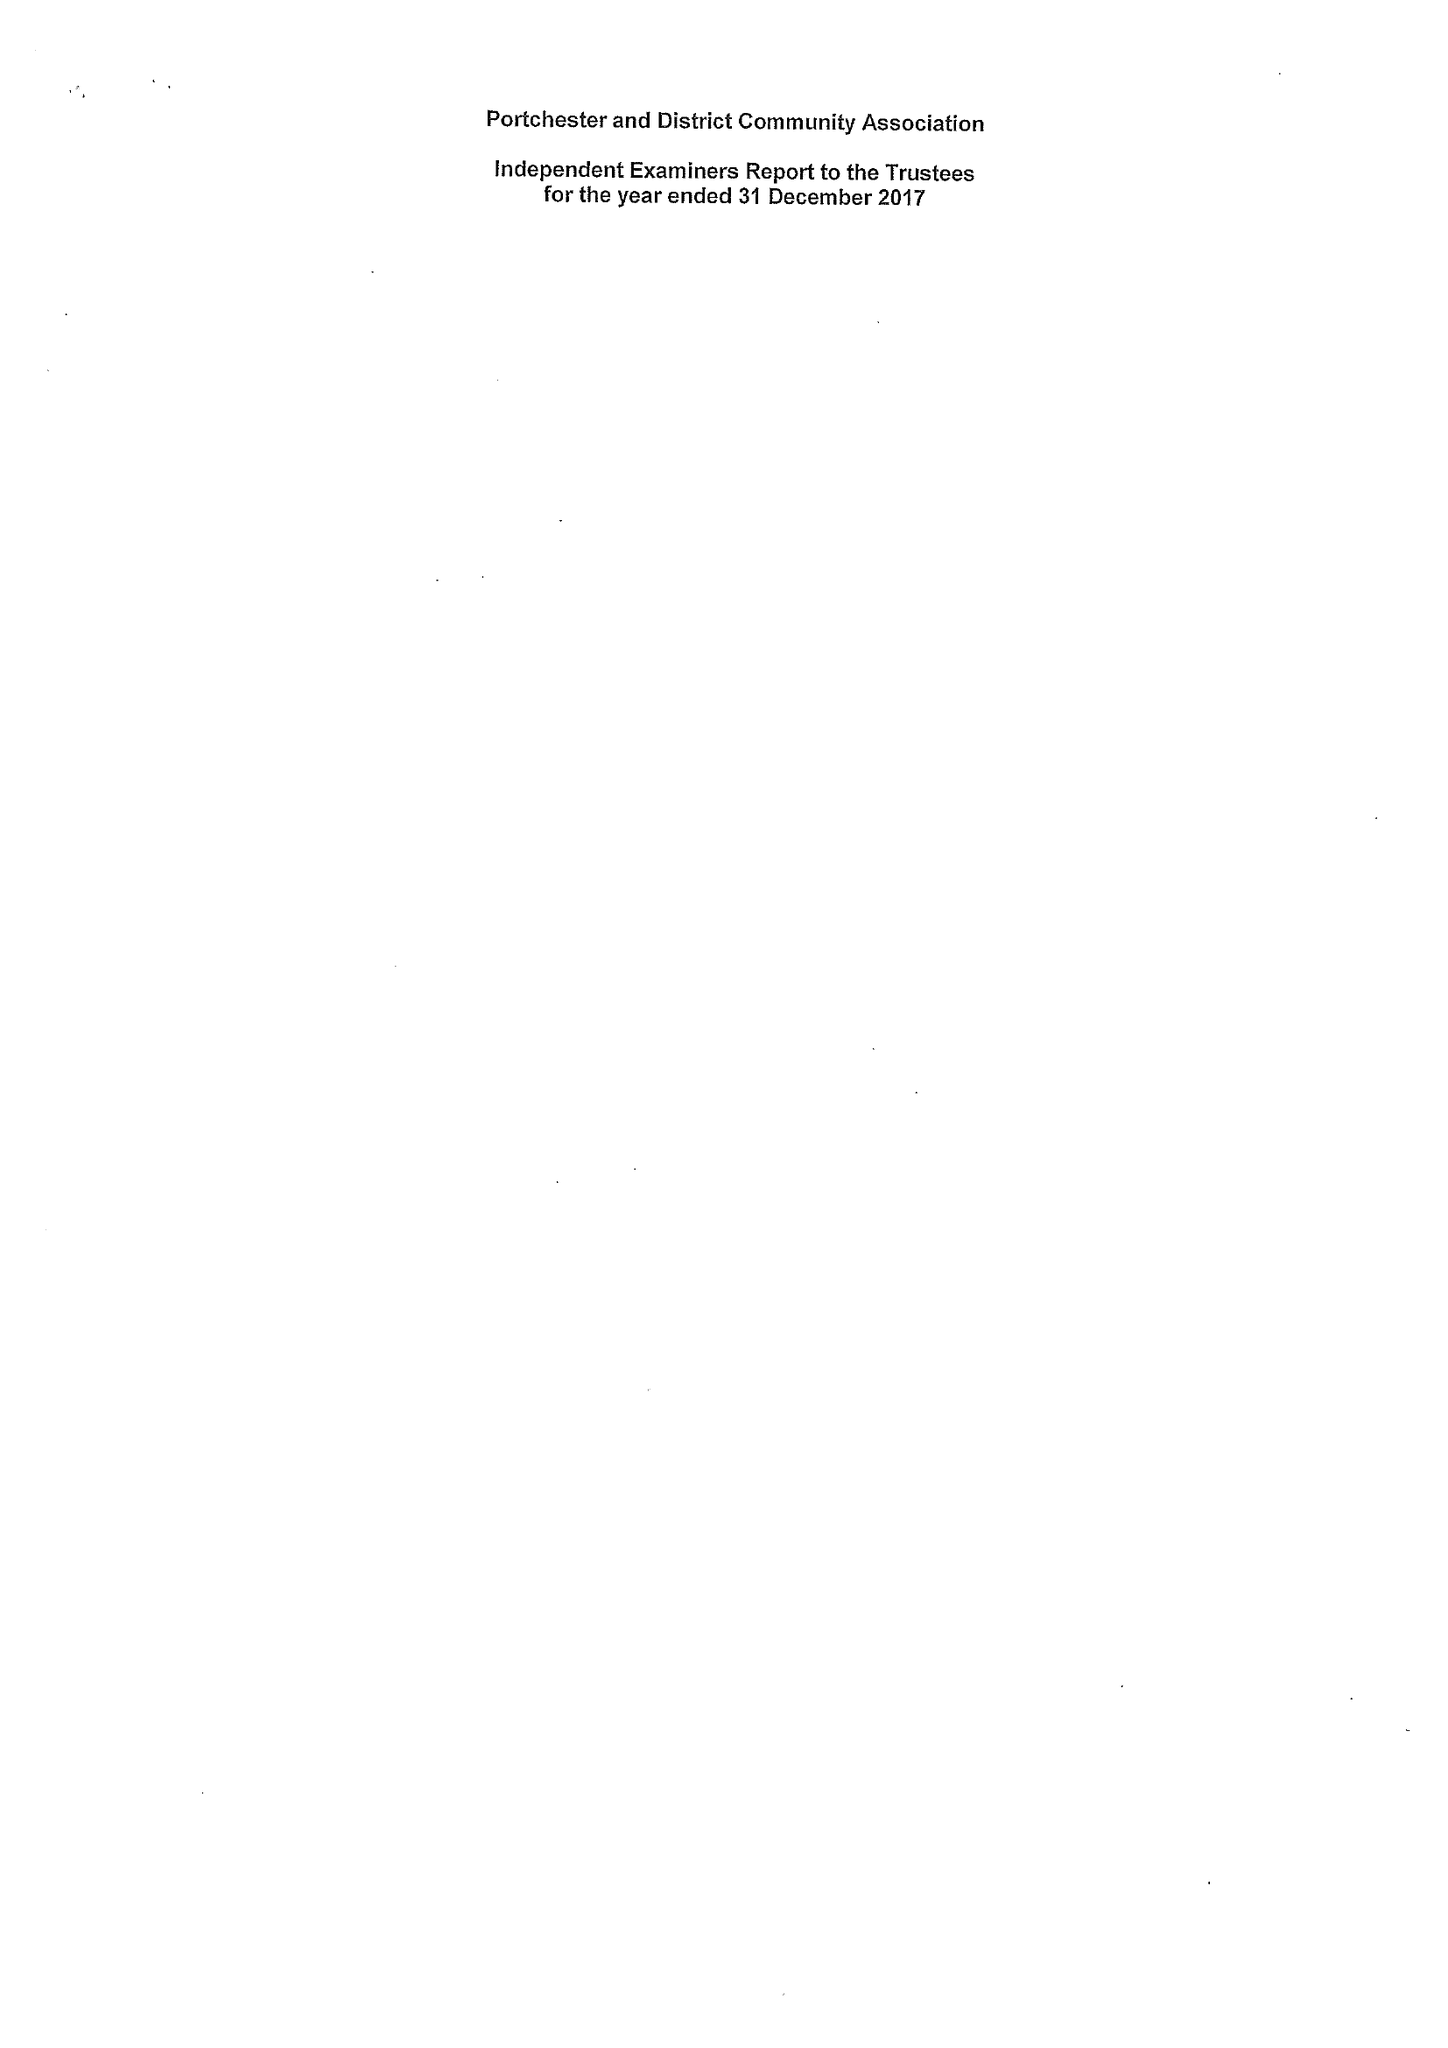What is the value for the spending_annually_in_british_pounds?
Answer the question using a single word or phrase. 149702.00 